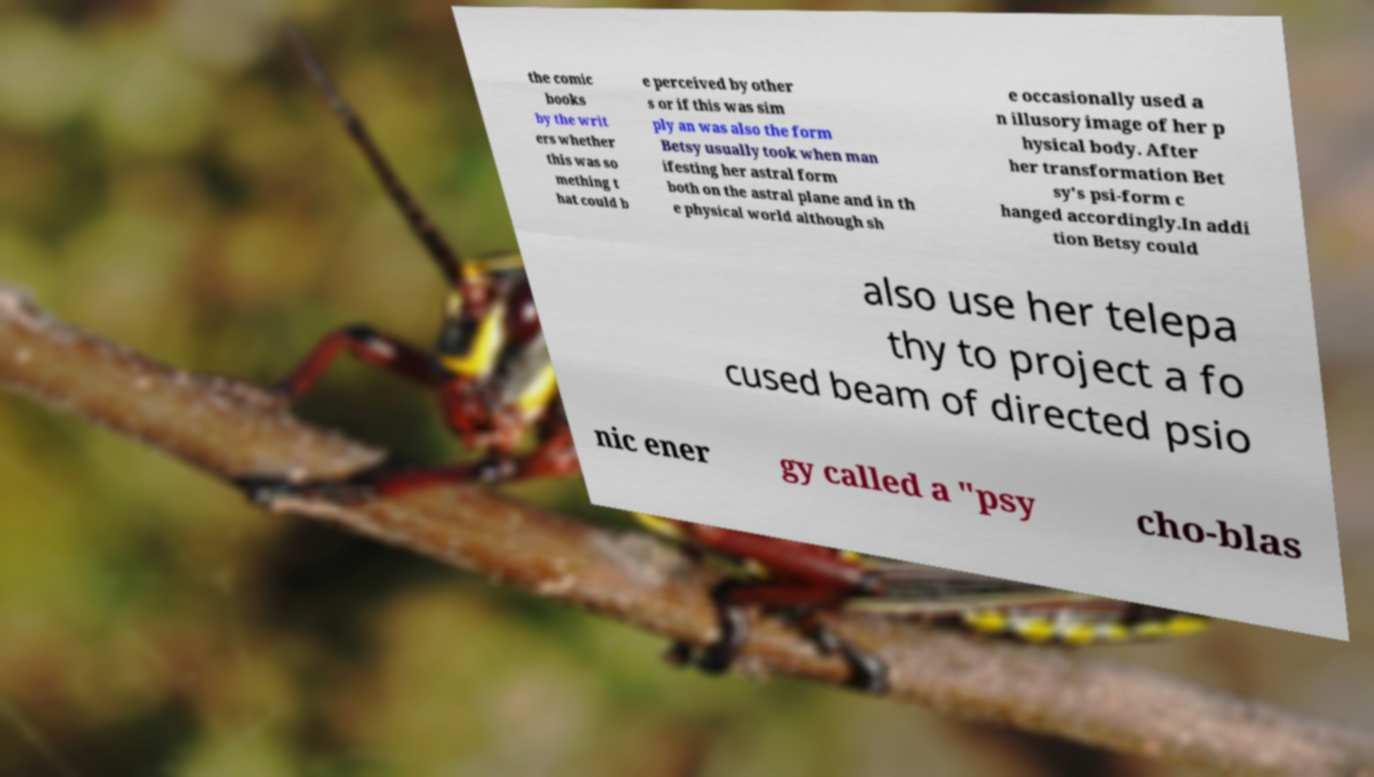Please identify and transcribe the text found in this image. the comic books by the writ ers whether this was so mething t hat could b e perceived by other s or if this was sim ply an was also the form Betsy usually took when man ifesting her astral form both on the astral plane and in th e physical world although sh e occasionally used a n illusory image of her p hysical body. After her transformation Bet sy's psi-form c hanged accordingly.In addi tion Betsy could also use her telepa thy to project a fo cused beam of directed psio nic ener gy called a "psy cho-blas 